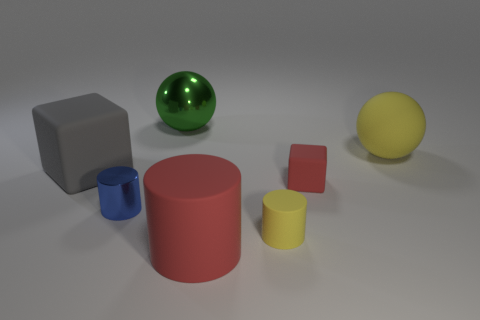What number of other objects are there of the same color as the matte ball?
Provide a succinct answer. 1. Is the number of large yellow rubber spheres right of the large yellow matte ball less than the number of large red matte cylinders that are behind the small red rubber thing?
Provide a short and direct response. No. How many things are either yellow rubber balls that are right of the green sphere or large yellow balls?
Give a very brief answer. 1. There is a yellow rubber cylinder; is its size the same as the ball that is on the right side of the metallic ball?
Your answer should be very brief. No. What size is the yellow rubber thing that is the same shape as the big green metal thing?
Offer a very short reply. Large. There is a matte block that is on the left side of the shiny thing that is behind the gray rubber cube; how many green metallic things are in front of it?
Your answer should be compact. 0. How many cylinders are blue shiny objects or yellow matte things?
Offer a very short reply. 2. There is a rubber thing to the left of the big object behind the big sphere right of the small red object; what color is it?
Give a very brief answer. Gray. How many other things are there of the same size as the green sphere?
Provide a short and direct response. 3. There is another matte object that is the same shape as the large gray thing; what is its color?
Keep it short and to the point. Red. 